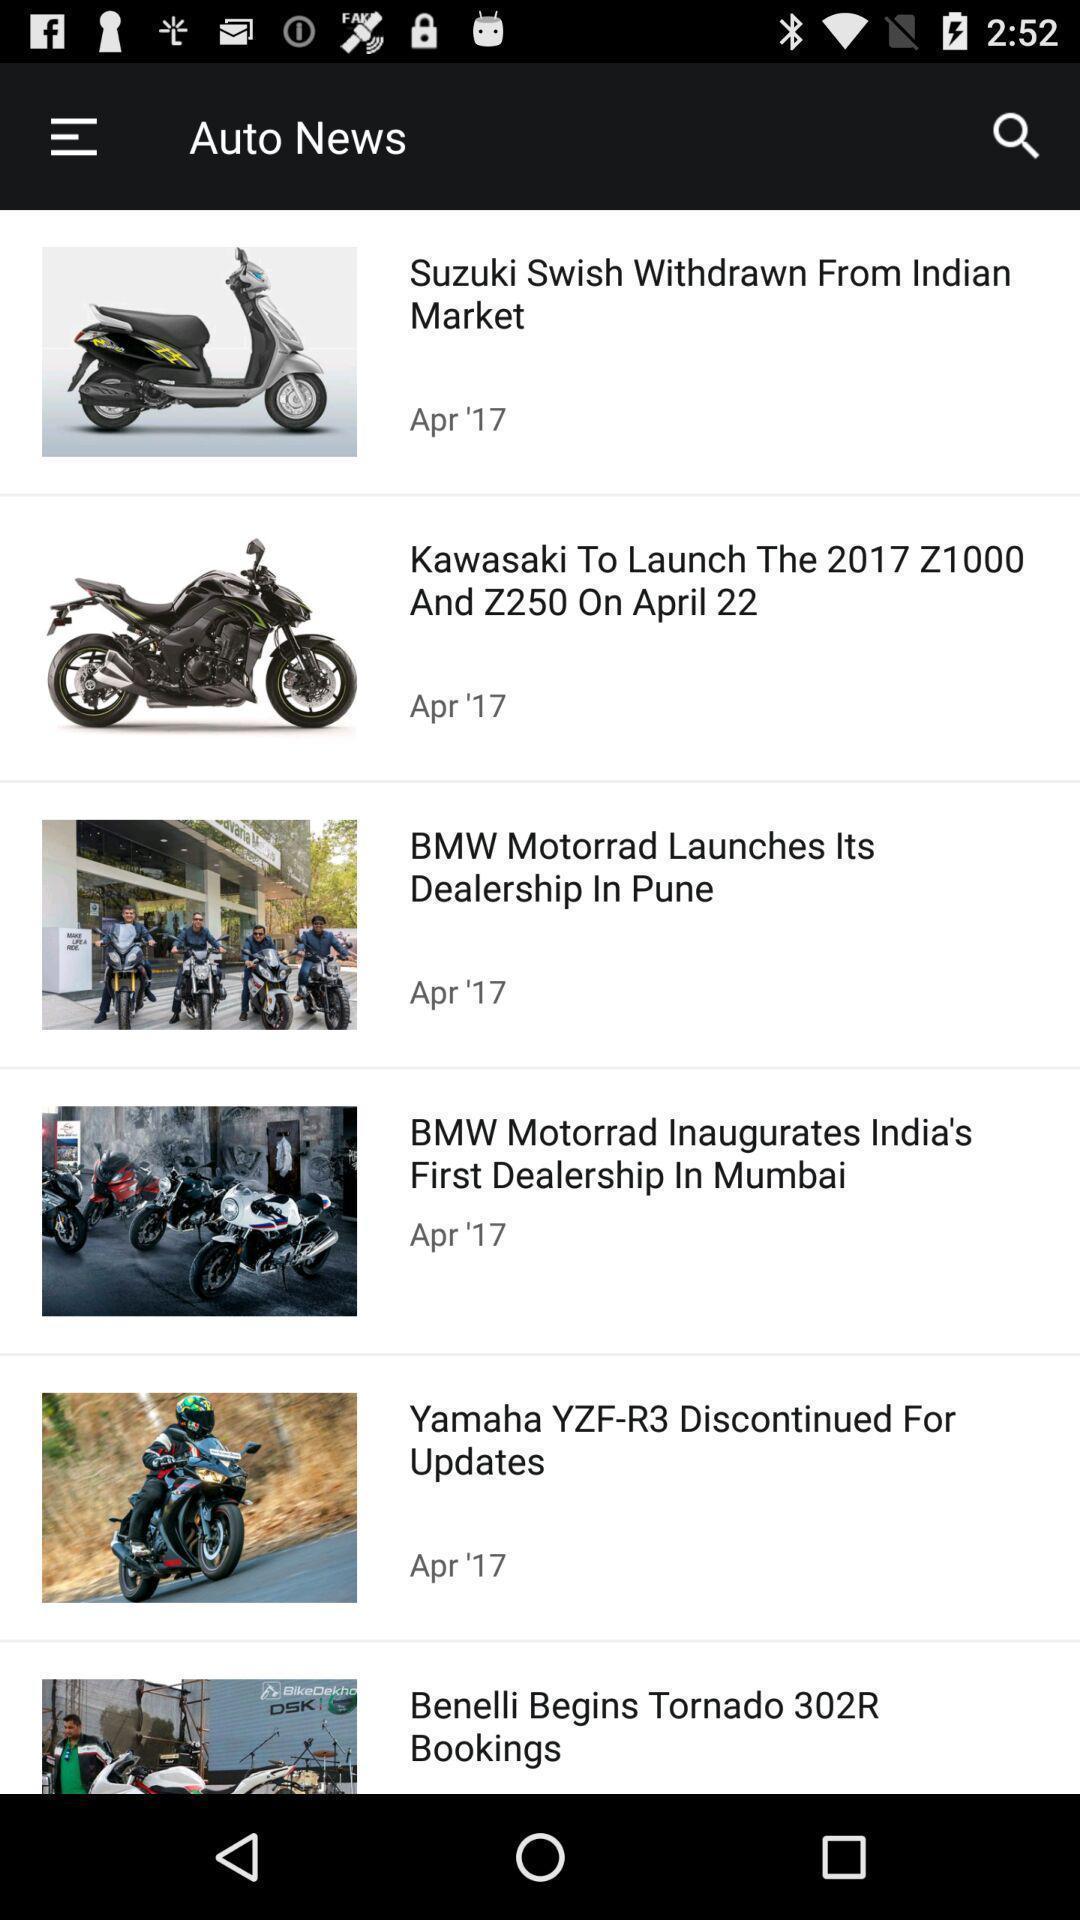Explain the elements present in this screenshot. Screen showing auto news page for a bikes. 